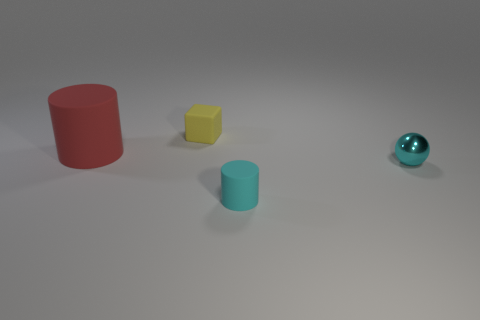Add 2 big yellow rubber blocks. How many objects exist? 6 Subtract all cubes. How many objects are left? 3 Subtract 2 cylinders. How many cylinders are left? 0 Subtract all blue balls. Subtract all yellow cubes. How many balls are left? 1 Subtract all yellow cubes. How many cyan cylinders are left? 1 Subtract all big matte things. Subtract all small cylinders. How many objects are left? 2 Add 4 cyan objects. How many cyan objects are left? 6 Add 1 red rubber cylinders. How many red rubber cylinders exist? 2 Subtract all red cylinders. How many cylinders are left? 1 Subtract 0 green balls. How many objects are left? 4 